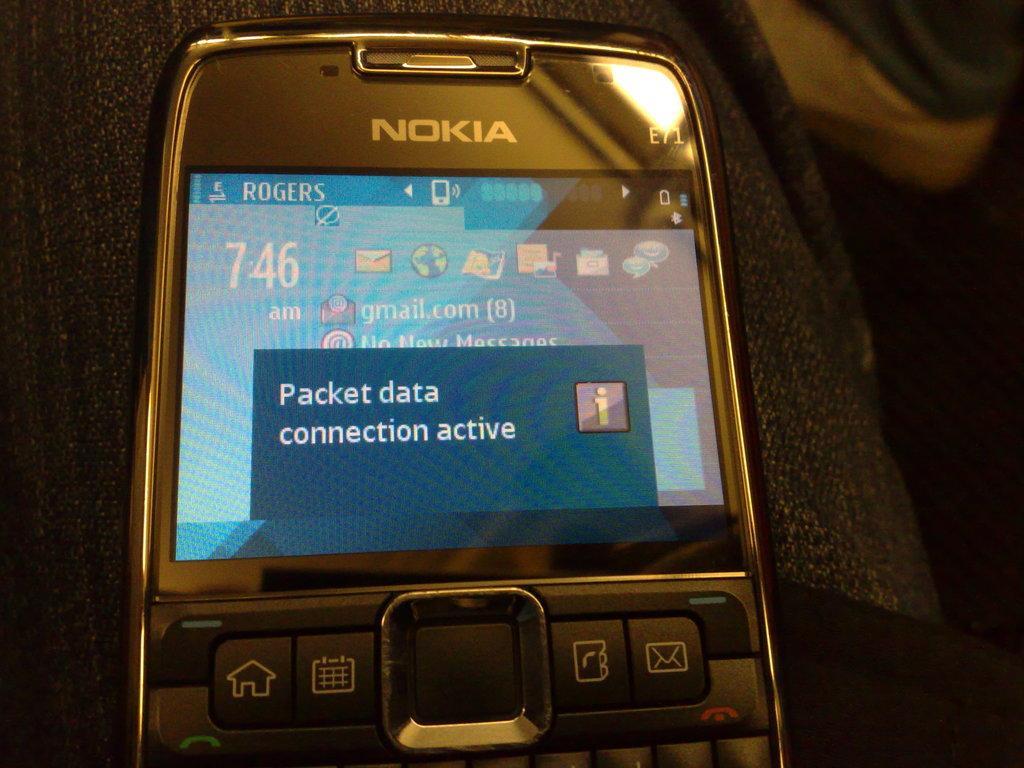Could you give a brief overview of what you see in this image? In this picture , in the middle there is a Nokia mobile and in the display it says packet data connection active. 